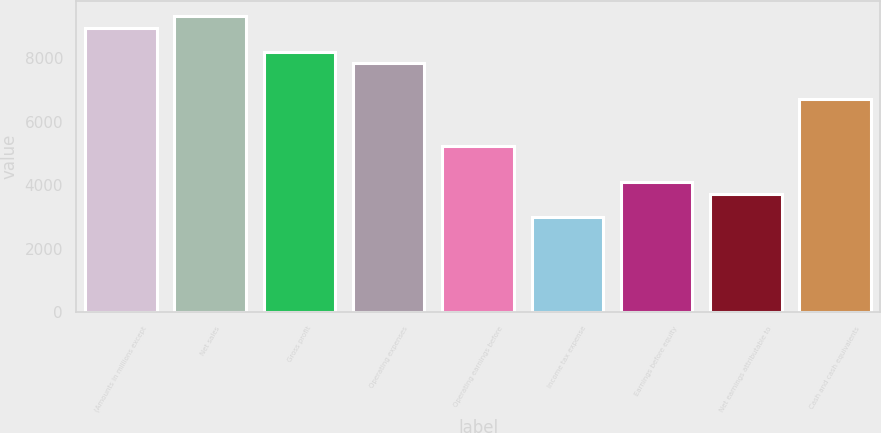<chart> <loc_0><loc_0><loc_500><loc_500><bar_chart><fcel>(Amounts in millions except<fcel>Net sales<fcel>Gross profit<fcel>Operating expenses<fcel>Operating earnings before<fcel>Income tax expense<fcel>Earnings before equity<fcel>Net earnings attributable to<fcel>Cash and cash equivalents<nl><fcel>8948.9<fcel>9321.72<fcel>8203.26<fcel>7830.44<fcel>5220.7<fcel>2983.78<fcel>4102.24<fcel>3729.42<fcel>6711.98<nl></chart> 